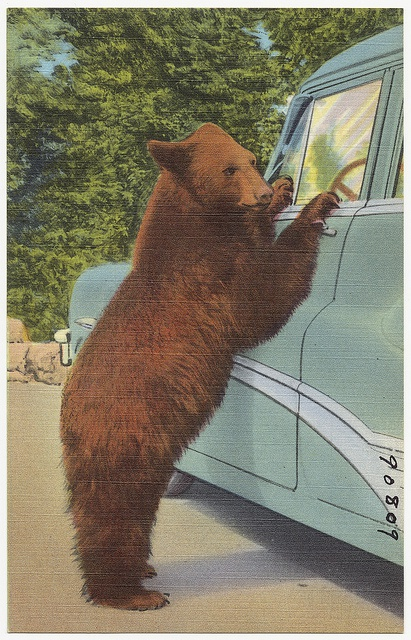Describe the objects in this image and their specific colors. I can see car in white, darkgray, gray, and lightgray tones and bear in white, maroon, and brown tones in this image. 